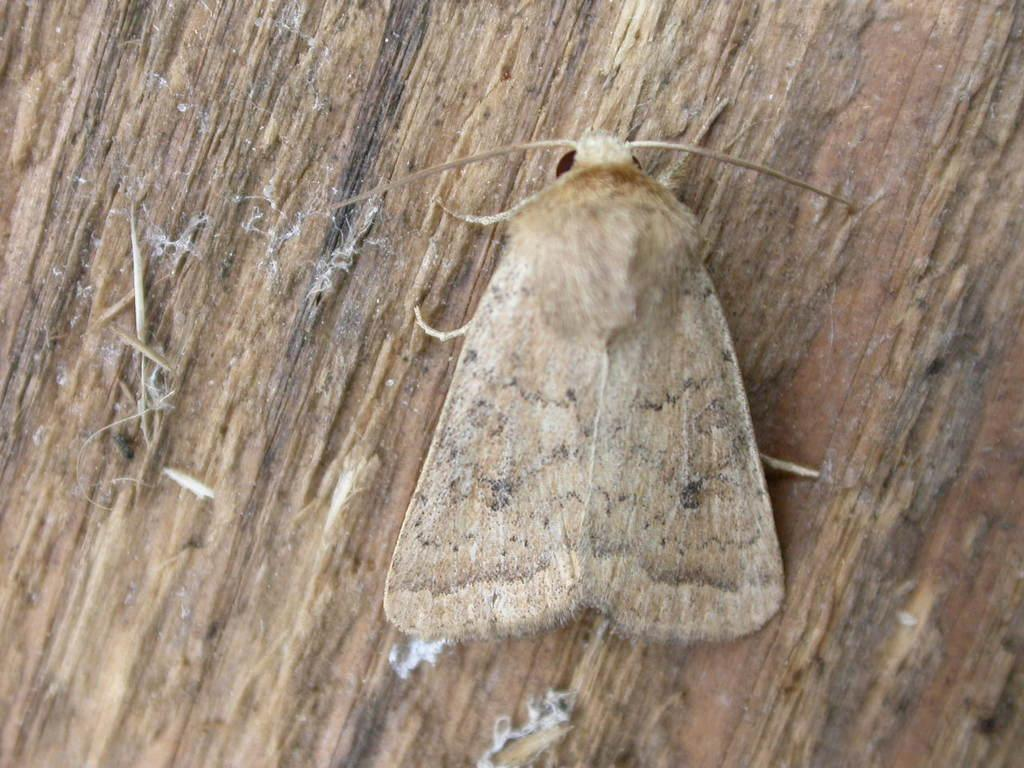What type of insect is in the image? There is a house moth in the image. What surface is the house moth on? The house moth is on a wooden surface. What level of respect does the house moth show towards the arm in the image? There is no arm present in the image, and therefore no interaction or respect can be observed between the house moth and an arm. 